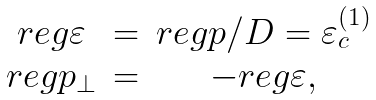Convert formula to latex. <formula><loc_0><loc_0><loc_500><loc_500>\begin{array} { c c c } r e g \varepsilon & = & r e g p / D = \varepsilon _ { c } ^ { ( 1 ) } \\ r e g p _ { \perp } & = & - r e g \varepsilon , \end{array}</formula> 